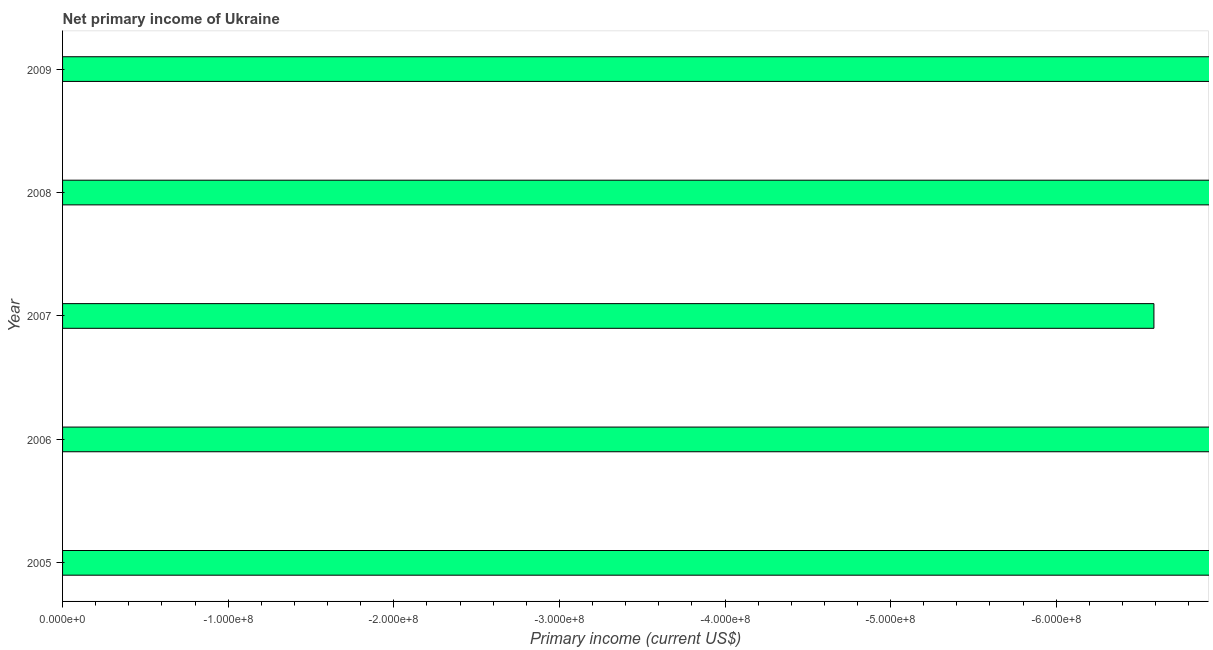Does the graph contain any zero values?
Give a very brief answer. Yes. What is the title of the graph?
Your answer should be very brief. Net primary income of Ukraine. What is the label or title of the X-axis?
Offer a terse response. Primary income (current US$). What is the amount of primary income in 2006?
Offer a terse response. 0. Across all years, what is the minimum amount of primary income?
Your response must be concise. 0. What is the average amount of primary income per year?
Your response must be concise. 0. What is the median amount of primary income?
Your response must be concise. 0. In how many years, is the amount of primary income greater than the average amount of primary income taken over all years?
Keep it short and to the point. 0. What is the difference between two consecutive major ticks on the X-axis?
Keep it short and to the point. 1.00e+08. Are the values on the major ticks of X-axis written in scientific E-notation?
Keep it short and to the point. Yes. What is the Primary income (current US$) in 2006?
Offer a very short reply. 0. What is the Primary income (current US$) of 2007?
Offer a very short reply. 0. What is the Primary income (current US$) of 2009?
Provide a short and direct response. 0. 